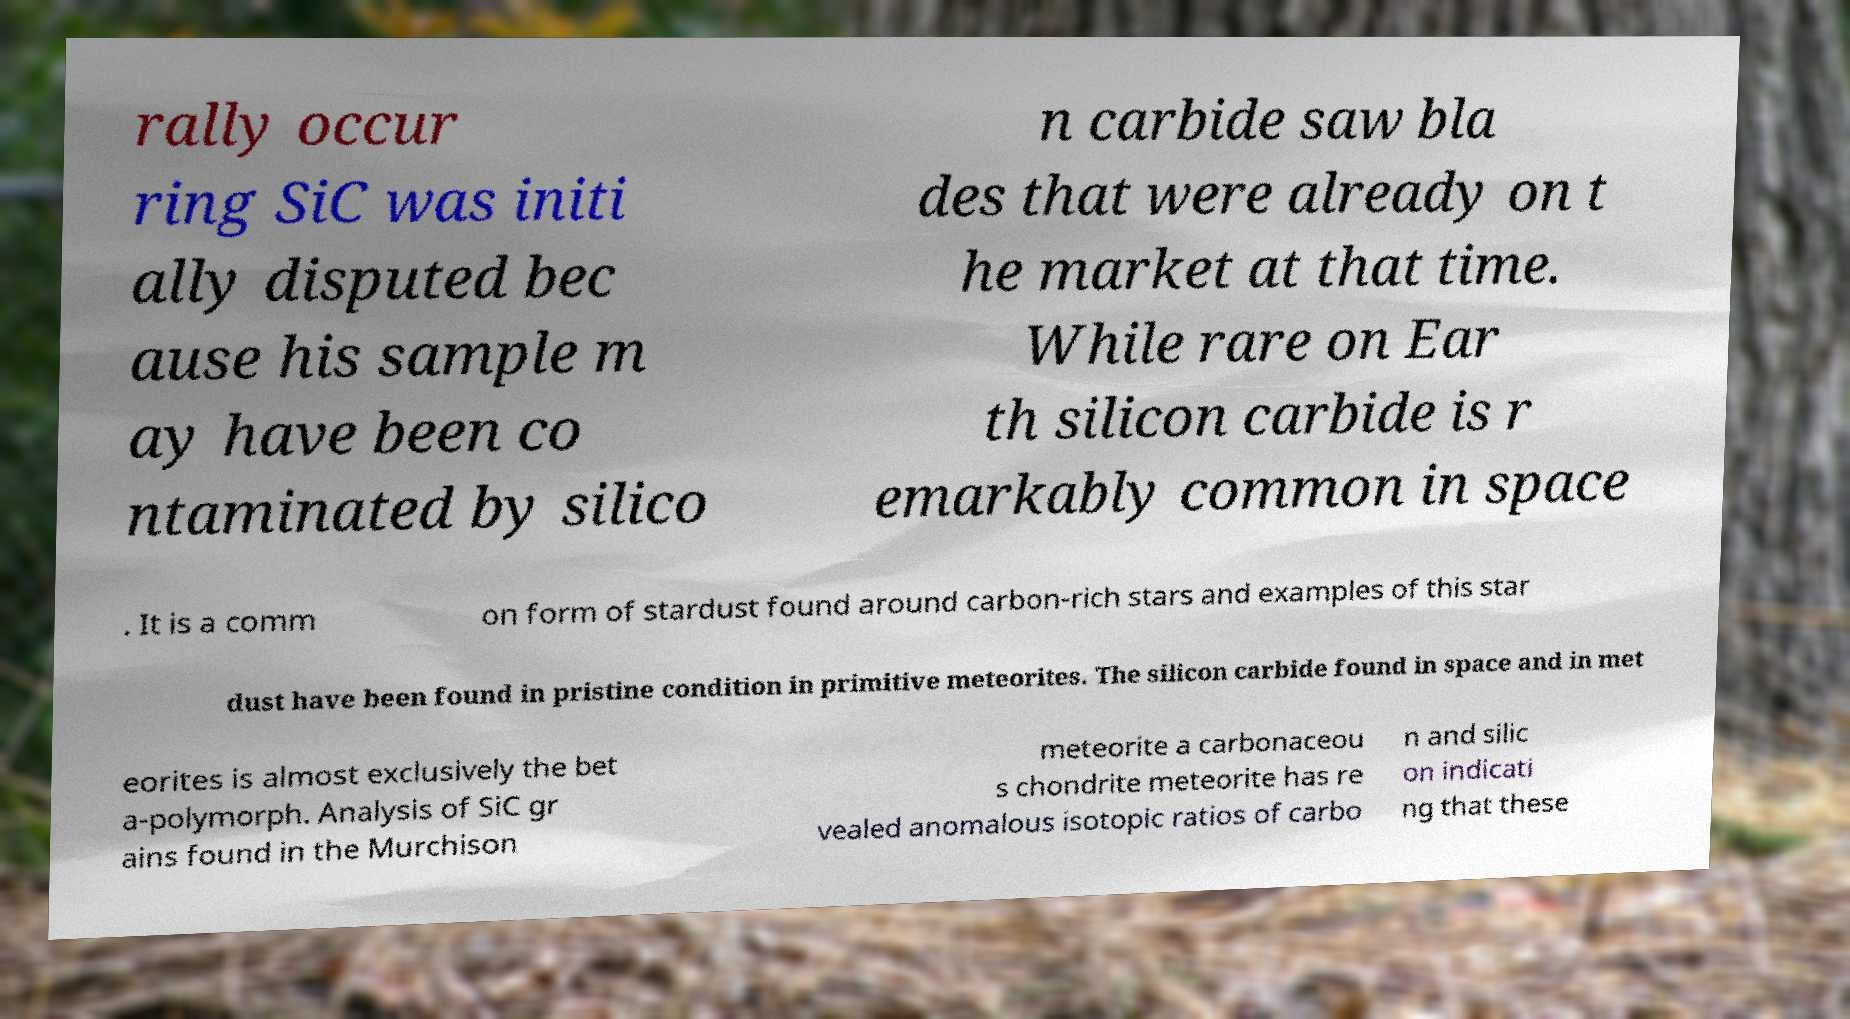For documentation purposes, I need the text within this image transcribed. Could you provide that? rally occur ring SiC was initi ally disputed bec ause his sample m ay have been co ntaminated by silico n carbide saw bla des that were already on t he market at that time. While rare on Ear th silicon carbide is r emarkably common in space . It is a comm on form of stardust found around carbon-rich stars and examples of this star dust have been found in pristine condition in primitive meteorites. The silicon carbide found in space and in met eorites is almost exclusively the bet a-polymorph. Analysis of SiC gr ains found in the Murchison meteorite a carbonaceou s chondrite meteorite has re vealed anomalous isotopic ratios of carbo n and silic on indicati ng that these 